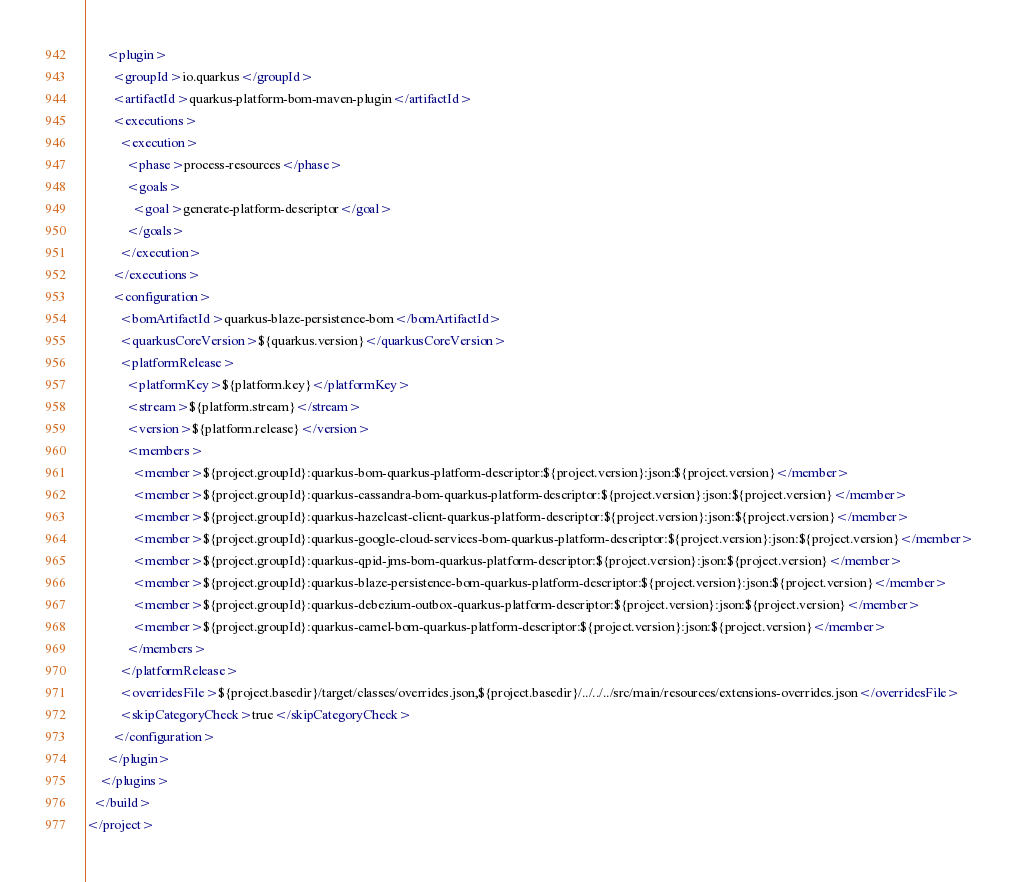Convert code to text. <code><loc_0><loc_0><loc_500><loc_500><_XML_>      <plugin>
        <groupId>io.quarkus</groupId>
        <artifactId>quarkus-platform-bom-maven-plugin</artifactId>
        <executions>
          <execution>
            <phase>process-resources</phase>
            <goals>
              <goal>generate-platform-descriptor</goal>
            </goals>
          </execution>
        </executions>
        <configuration>
          <bomArtifactId>quarkus-blaze-persistence-bom</bomArtifactId>
          <quarkusCoreVersion>${quarkus.version}</quarkusCoreVersion>
          <platformRelease>
            <platformKey>${platform.key}</platformKey>
            <stream>${platform.stream}</stream>
            <version>${platform.release}</version>
            <members>
              <member>${project.groupId}:quarkus-bom-quarkus-platform-descriptor:${project.version}:json:${project.version}</member>
              <member>${project.groupId}:quarkus-cassandra-bom-quarkus-platform-descriptor:${project.version}:json:${project.version}</member>
              <member>${project.groupId}:quarkus-hazelcast-client-quarkus-platform-descriptor:${project.version}:json:${project.version}</member>
              <member>${project.groupId}:quarkus-google-cloud-services-bom-quarkus-platform-descriptor:${project.version}:json:${project.version}</member>
              <member>${project.groupId}:quarkus-qpid-jms-bom-quarkus-platform-descriptor:${project.version}:json:${project.version}</member>
              <member>${project.groupId}:quarkus-blaze-persistence-bom-quarkus-platform-descriptor:${project.version}:json:${project.version}</member>
              <member>${project.groupId}:quarkus-debezium-outbox-quarkus-platform-descriptor:${project.version}:json:${project.version}</member>
              <member>${project.groupId}:quarkus-camel-bom-quarkus-platform-descriptor:${project.version}:json:${project.version}</member>
            </members>
          </platformRelease>
          <overridesFile>${project.basedir}/target/classes/overrides.json,${project.basedir}/../../../src/main/resources/extensions-overrides.json</overridesFile>
          <skipCategoryCheck>true</skipCategoryCheck>
        </configuration>
      </plugin>
    </plugins>
  </build>
</project>
</code> 